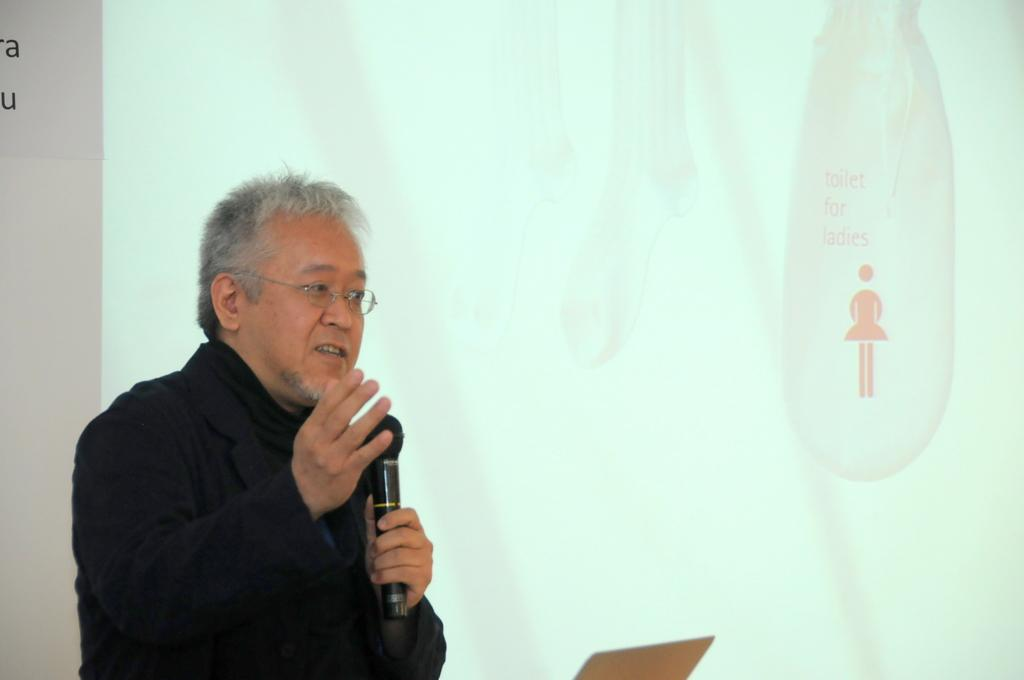Who is the main subject in the image? There is a person standing in the front of the image. What is the person holding in the image? The person is holding a microphone. What is the person doing with the microphone? The person is speaking. What can be seen in the background of the image? There is a screen in the background of the image. What is displayed on the screen? There is text and an image on the screen. What color is the curtain behind the person in the image? There is no curtain visible in the image. How many roses are on the screen in the image? There is no rose present in the image; only text and an image are displayed on the screen. 